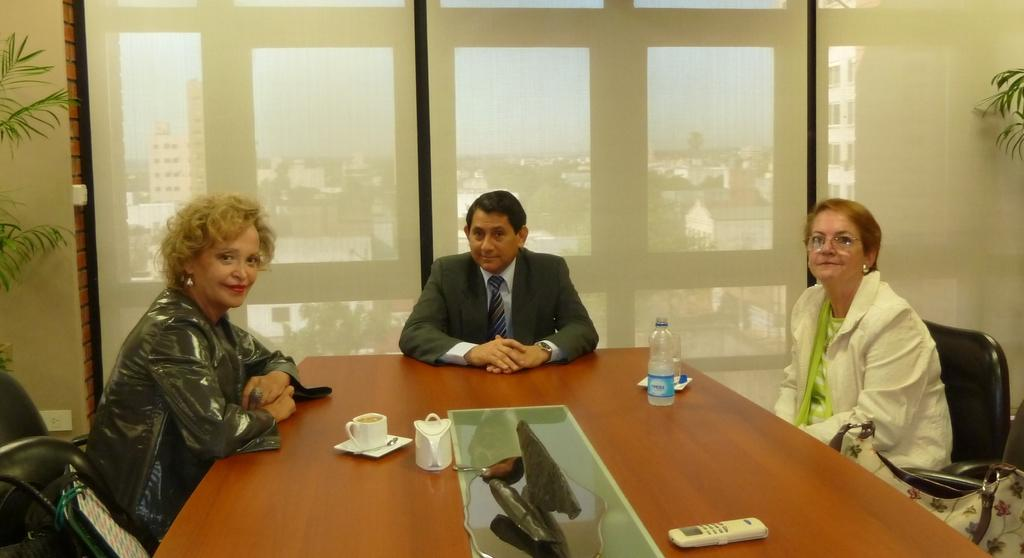How many people are in the image? There are three persons in the image. What are the persons doing? The persons are sitting. What is the emotional state of the persons? The persons are smiling. What is located in front of the persons? There is a table in front of the persons. What items can be seen on the table? There is a water bottle and a cup on the table. What rule is being enforced in the image? There is no rule being enforced in the image. 